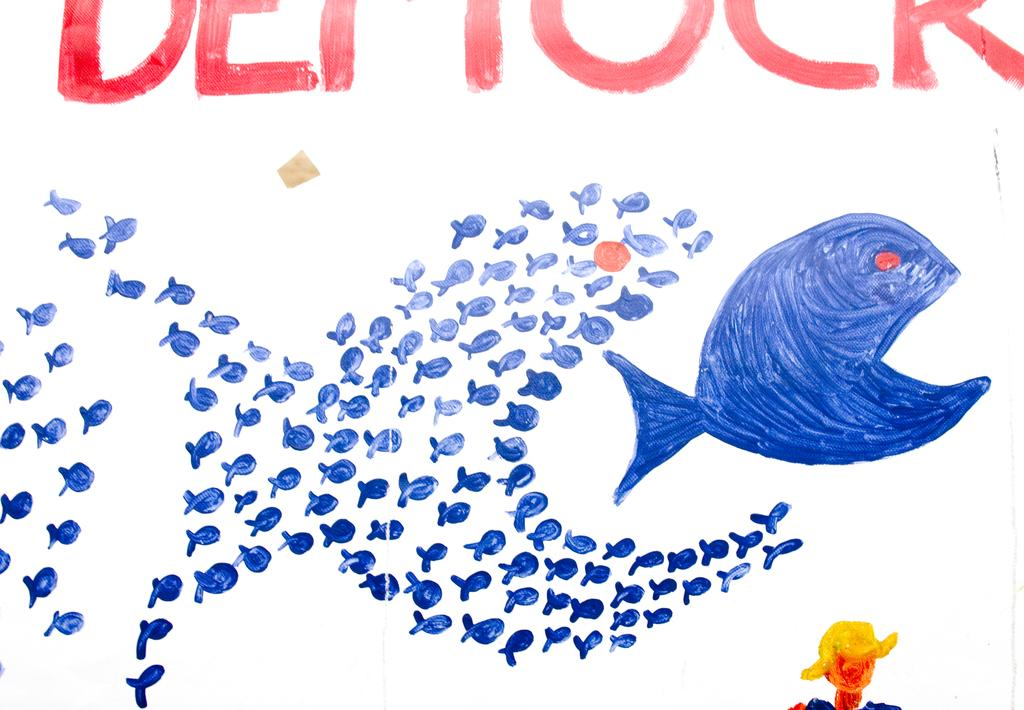What is depicted in the paintings in the image? There are paintings of fishes in the image. What can be seen at the top of the image? There is text at the top of the image. What color is the background of the image? The background of the image is white. What type of music can be heard playing in the background of the image? There is no music present in the image; it only contains paintings of fishes, text, and a white background. 